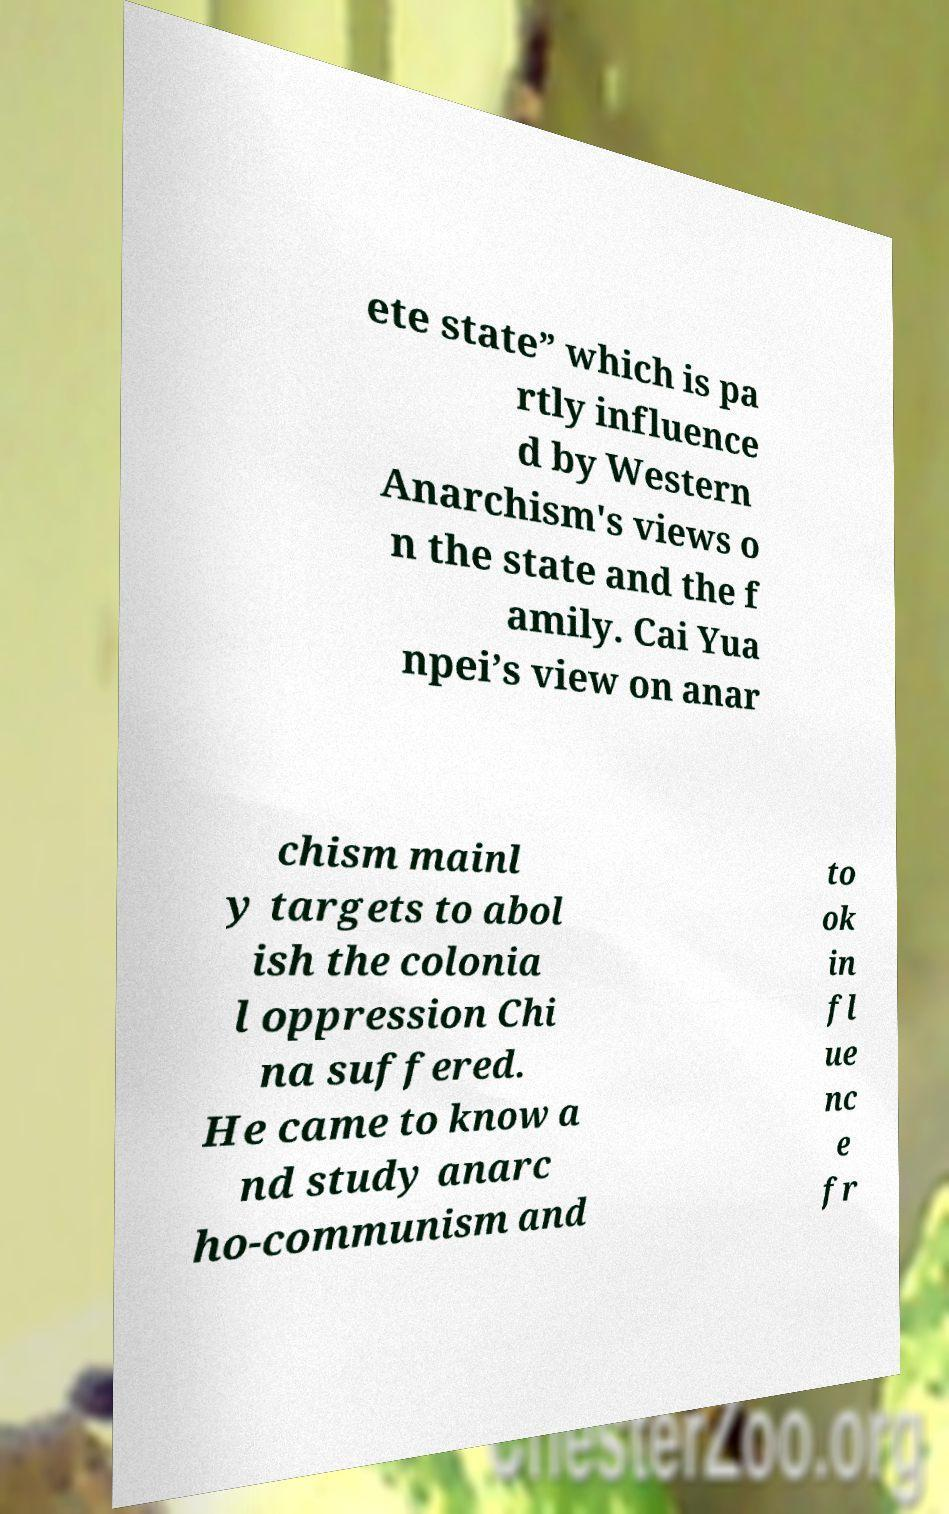Can you read and provide the text displayed in the image?This photo seems to have some interesting text. Can you extract and type it out for me? ete state” which is pa rtly influence d by Western Anarchism's views o n the state and the f amily. Cai Yua npei’s view on anar chism mainl y targets to abol ish the colonia l oppression Chi na suffered. He came to know a nd study anarc ho-communism and to ok in fl ue nc e fr 